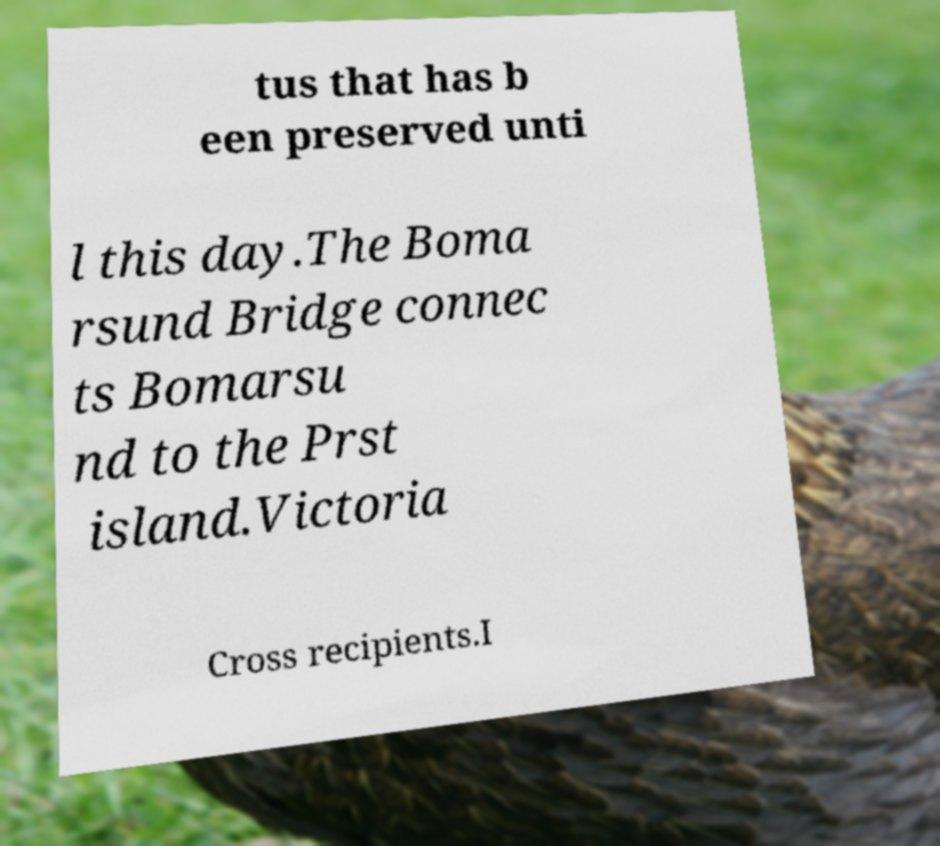Could you extract and type out the text from this image? tus that has b een preserved unti l this day.The Boma rsund Bridge connec ts Bomarsu nd to the Prst island.Victoria Cross recipients.I 